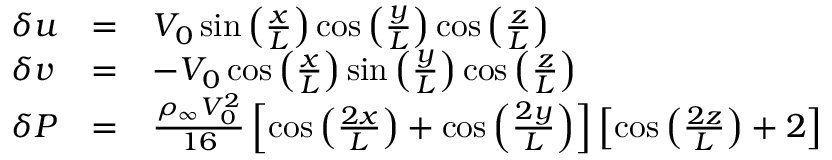Convert formula to latex. <formula><loc_0><loc_0><loc_500><loc_500>\begin{array} { r } { \begin{array} { l l l } { \delta u } & { = } & { V _ { 0 } \sin \left ( \frac { x } { L } \right ) \cos \left ( \frac { y } { L } \right ) \cos \left ( \frac { z } { L } \right ) } \\ { \delta v } & { = } & { - V _ { 0 } \cos \left ( \frac { x } { L } \right ) \sin \left ( \frac { y } { L } \right ) \cos \left ( \frac { z } { L } \right ) } \\ { \delta P } & { = } & { \frac { \rho _ { \infty } V _ { 0 } ^ { 2 } } { 1 6 } \left [ \cos \left ( \frac { 2 x } { L } \right ) + \cos \left ( \frac { 2 y } { L } \right ) \right ] \left [ \cos \left ( \frac { 2 z } { L } \right ) + 2 \right ] } \end{array} } \end{array}</formula> 